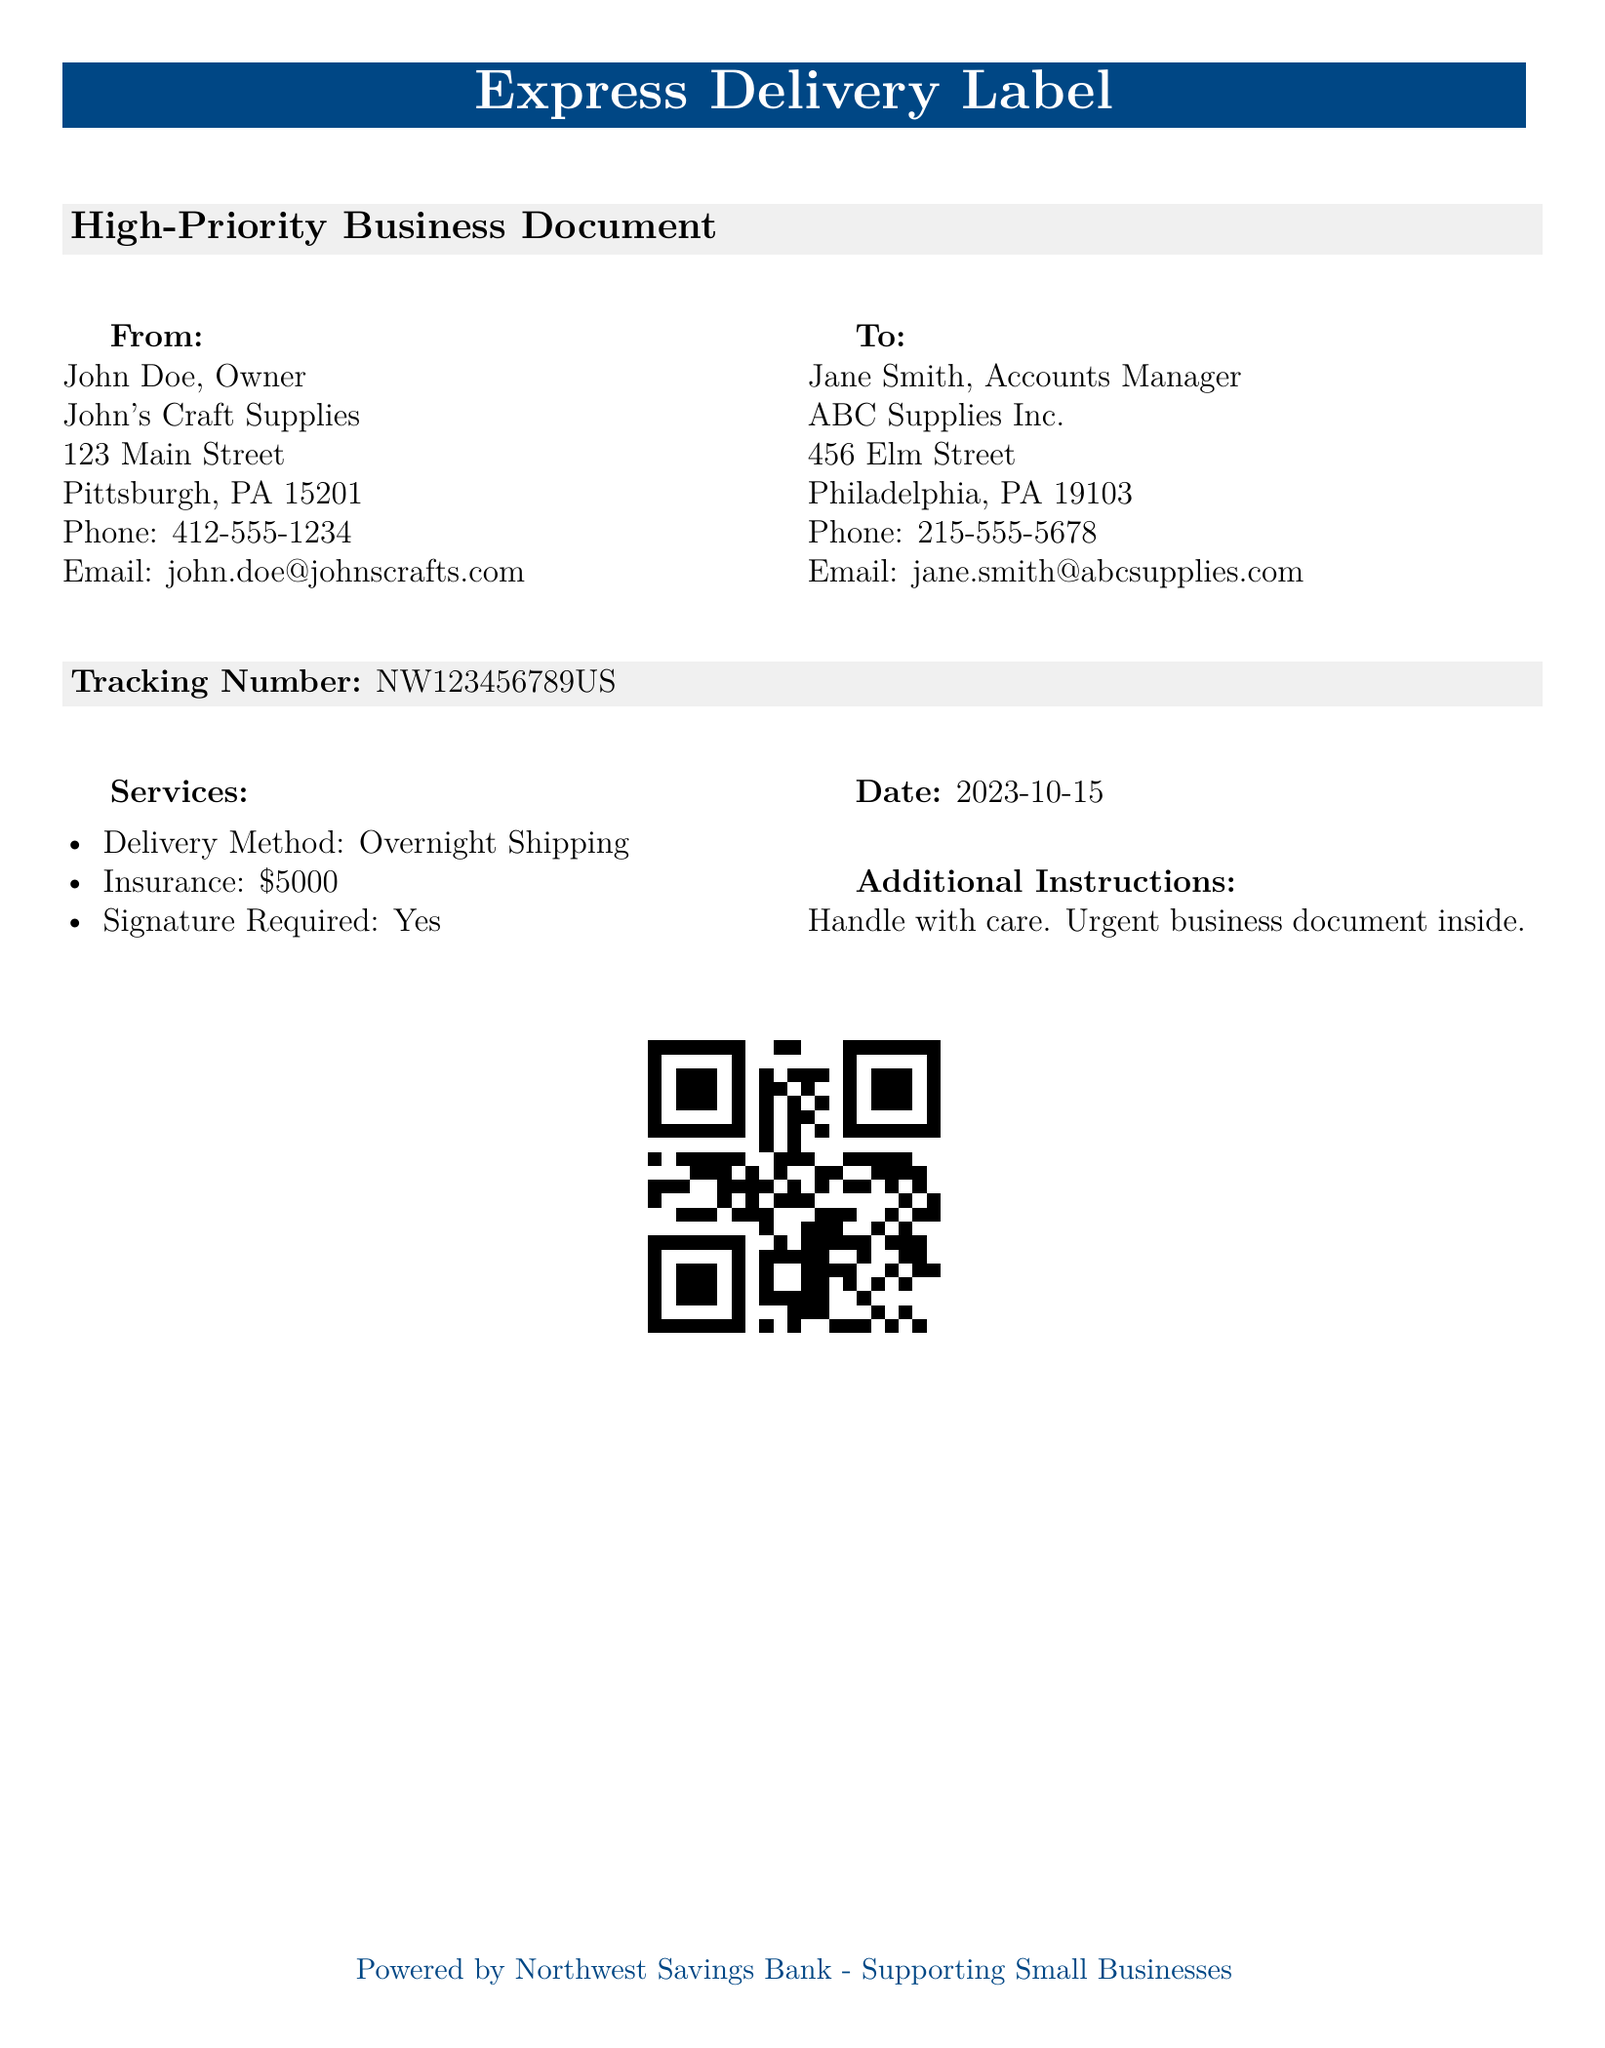What is the sender's name? The sender's name is listed at the top under the "From" section.
Answer: John Doe What is the tracking number? The tracking number is a specific identifier mentioned in the document for tracking purposes.
Answer: NW123456789US What is the delivery method? The delivery method is indicated in the "Services" section of the document.
Answer: Overnight Shipping Who is the recipient's accounts manager? The name of the accounts manager is mentioned under the "To" section.
Answer: Jane Smith What is the insurance amount for this shipment? The insurance amount is specified in the "Services" section.
Answer: $5000 What is the date of shipment? The date is stated in the document, indicating when the shipment is sent.
Answer: 2023-10-15 Is a signature required upon delivery? The requirement for a signature is noted among the listed services.
Answer: Yes What are the additional instructions for handling the document? The additional instructions for the package are provided towards the end of the document.
Answer: Handle with care. Urgent business document inside What business does the sender own? The sender's business name is found in the "From" section.
Answer: John's Craft Supplies 